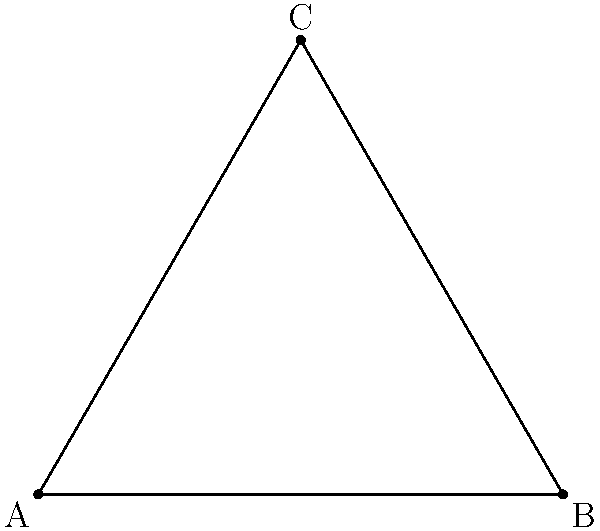Consider the symmetry group of an equilateral triangle acting on its vertices {A, B, C}. If we choose a random element of this group, what is the probability that vertex A remains fixed (stabilized)? Explain your answer using the orbit-stabilizer theorem. To solve this problem, we'll use the orbit-stabilizer theorem and our knowledge of the symmetry group of an equilateral triangle. Let's break it down step-by-step:

1) First, recall the symmetry group of an equilateral triangle:
   - It has 6 elements: 3 rotations (0°, 120°, 240°) and 3 reflections.

2) The orbit-stabilizer theorem states that for a group G acting on a set X, and for any x in X:
   $$ |G| = |Orbit(x)| \cdot |Stab(x)| $$
   where |G| is the order of the group, |Orbit(x)| is the size of the orbit of x, and |Stab(x)| is the size of the stabilizer of x.

3) In our case:
   - |G| = 6 (the order of the symmetry group)
   - We want to find |Stab(A)| (the size of the stabilizer of vertex A)

4) To find |Stab(A)|, let's count the symmetries that fix A:
   - The identity transformation (always fixes all points)
   - The reflection across the altitude from A

5) So, |Stab(A)| = 2

6) Using the orbit-stabilizer theorem:
   $$ 6 = |Orbit(A)| \cdot 2 $$
   $$ |Orbit(A)| = 3 $$

7) This makes sense, as A can be moved to any of the 3 vertices.

8) The probability of A remaining fixed is the number of elements in Stab(A) divided by the total number of elements in G:
   $$ P(A \text{ fixed}) = \frac{|Stab(A)|}{|G|} = \frac{2}{6} = \frac{1}{3} $$
Answer: $\frac{1}{3}$ 